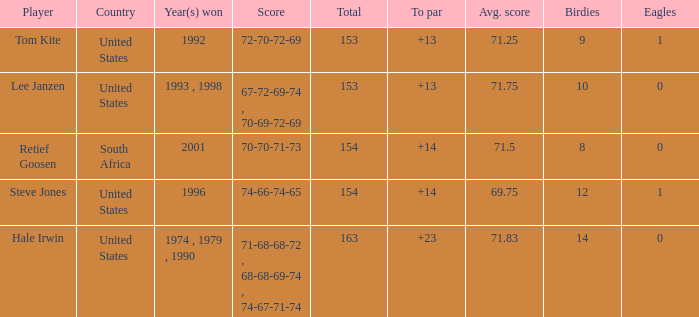What is the highest to par that is less than 153 None. 